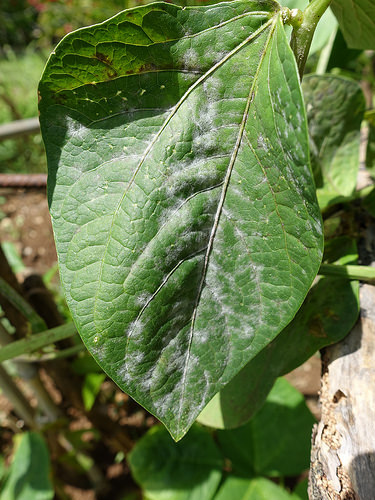<image>
Is the leaf on the rock? No. The leaf is not positioned on the rock. They may be near each other, but the leaf is not supported by or resting on top of the rock. 